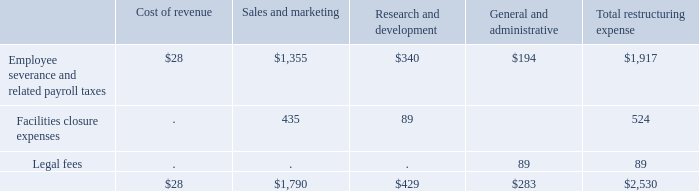Restructuring Expense
In October 2019, we began implementing a restructuring plan in our ongoing efforts to reduce operating costs and focus on advanced technologies. The restructuring plan, when complete, is expected to result in a workforce reduction of approximately 5% of our workforce and the closure and consolidation of certain U.S. and international office facilities. We expect to complete the restructuring by the end of the second fiscal quarter of 2020. We recorded restructuring expenses of $2.5 million in the fourth quarter of 2019, which included the following (in thousands)
As of December 31, 2019, we had accrued but unpaid restructuring costs of $1.5 million included in accrued liabilities on the Consolidated Balance Sheets
What are the three categories of restructuring expenses? Employee severance and related payroll taxes, facilities closure expenses, legal fees. What is the change in workforce as a result of the restructuring? Reduction of approximately 5%. What is the restructuring costs incurred by the company?
Answer scale should be: thousand. $2,530. What is the proportion of the cost of revenue and research and development expenses as a percentage of the total restructuring expense?
Answer scale should be: percent. ($28 + $429)/$2,530 
Answer: 18.06. What is the total legal fees and facilities expenses?
Answer scale should be: thousand. 89+524
Answer: 613. What is the total Sales and marketing and General and administrative?
Answer scale should be: thousand. 1,790+283
Answer: 2073. 